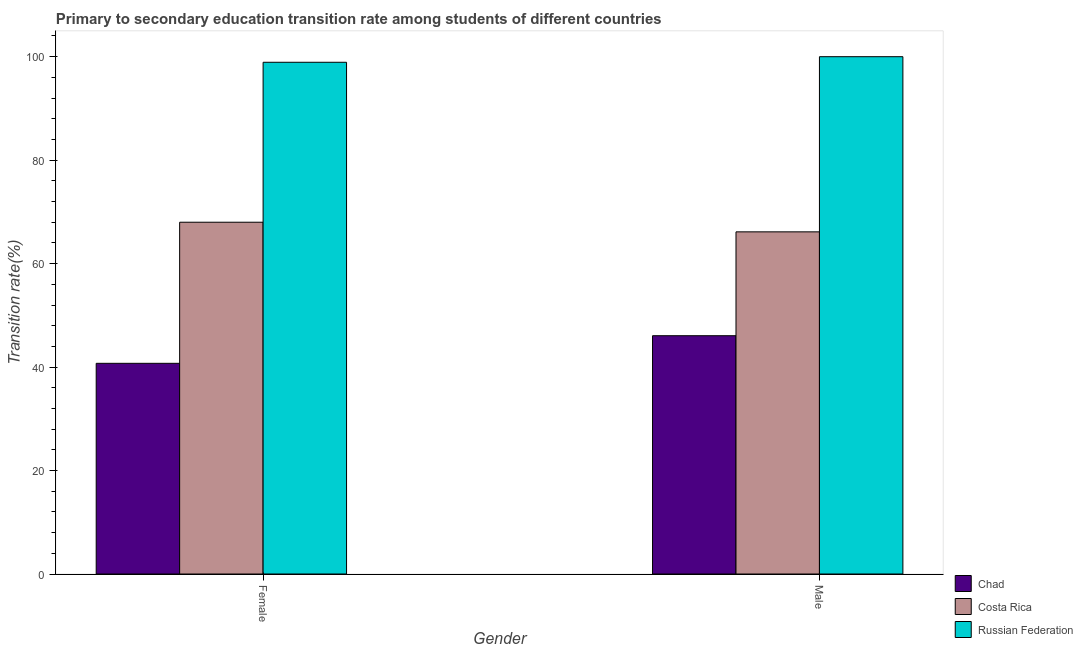How many different coloured bars are there?
Your answer should be very brief. 3. Are the number of bars per tick equal to the number of legend labels?
Offer a terse response. Yes. Are the number of bars on each tick of the X-axis equal?
Offer a very short reply. Yes. How many bars are there on the 1st tick from the left?
Keep it short and to the point. 3. How many bars are there on the 1st tick from the right?
Provide a succinct answer. 3. What is the label of the 2nd group of bars from the left?
Make the answer very short. Male. What is the transition rate among female students in Chad?
Provide a short and direct response. 40.73. Across all countries, what is the maximum transition rate among female students?
Your answer should be compact. 98.92. Across all countries, what is the minimum transition rate among female students?
Offer a terse response. 40.73. In which country was the transition rate among female students maximum?
Provide a short and direct response. Russian Federation. In which country was the transition rate among male students minimum?
Your answer should be very brief. Chad. What is the total transition rate among female students in the graph?
Provide a short and direct response. 207.65. What is the difference between the transition rate among male students in Russian Federation and that in Costa Rica?
Make the answer very short. 33.86. What is the difference between the transition rate among male students in Chad and the transition rate among female students in Russian Federation?
Make the answer very short. -52.86. What is the average transition rate among male students per country?
Give a very brief answer. 70.73. What is the difference between the transition rate among male students and transition rate among female students in Russian Federation?
Your response must be concise. 1.08. What is the ratio of the transition rate among female students in Costa Rica to that in Chad?
Offer a terse response. 1.67. Is the transition rate among male students in Russian Federation less than that in Chad?
Ensure brevity in your answer.  No. What does the 1st bar from the left in Male represents?
Your answer should be compact. Chad. What does the 2nd bar from the right in Male represents?
Give a very brief answer. Costa Rica. Are all the bars in the graph horizontal?
Your answer should be very brief. No. What is the difference between two consecutive major ticks on the Y-axis?
Your response must be concise. 20. Are the values on the major ticks of Y-axis written in scientific E-notation?
Keep it short and to the point. No. Does the graph contain grids?
Offer a very short reply. No. How are the legend labels stacked?
Keep it short and to the point. Vertical. What is the title of the graph?
Your answer should be compact. Primary to secondary education transition rate among students of different countries. Does "Nepal" appear as one of the legend labels in the graph?
Provide a succinct answer. No. What is the label or title of the Y-axis?
Offer a terse response. Transition rate(%). What is the Transition rate(%) of Chad in Female?
Ensure brevity in your answer.  40.73. What is the Transition rate(%) of Costa Rica in Female?
Offer a terse response. 68. What is the Transition rate(%) in Russian Federation in Female?
Give a very brief answer. 98.92. What is the Transition rate(%) of Chad in Male?
Provide a succinct answer. 46.06. What is the Transition rate(%) in Costa Rica in Male?
Your answer should be very brief. 66.14. Across all Gender, what is the maximum Transition rate(%) in Chad?
Provide a short and direct response. 46.06. Across all Gender, what is the maximum Transition rate(%) of Costa Rica?
Keep it short and to the point. 68. Across all Gender, what is the maximum Transition rate(%) in Russian Federation?
Offer a very short reply. 100. Across all Gender, what is the minimum Transition rate(%) of Chad?
Your answer should be very brief. 40.73. Across all Gender, what is the minimum Transition rate(%) of Costa Rica?
Give a very brief answer. 66.14. Across all Gender, what is the minimum Transition rate(%) in Russian Federation?
Make the answer very short. 98.92. What is the total Transition rate(%) of Chad in the graph?
Provide a succinct answer. 86.79. What is the total Transition rate(%) of Costa Rica in the graph?
Offer a very short reply. 134.14. What is the total Transition rate(%) of Russian Federation in the graph?
Keep it short and to the point. 198.92. What is the difference between the Transition rate(%) of Chad in Female and that in Male?
Keep it short and to the point. -5.34. What is the difference between the Transition rate(%) of Costa Rica in Female and that in Male?
Keep it short and to the point. 1.86. What is the difference between the Transition rate(%) in Russian Federation in Female and that in Male?
Offer a very short reply. -1.08. What is the difference between the Transition rate(%) of Chad in Female and the Transition rate(%) of Costa Rica in Male?
Keep it short and to the point. -25.42. What is the difference between the Transition rate(%) in Chad in Female and the Transition rate(%) in Russian Federation in Male?
Offer a terse response. -59.27. What is the difference between the Transition rate(%) of Costa Rica in Female and the Transition rate(%) of Russian Federation in Male?
Make the answer very short. -32. What is the average Transition rate(%) in Chad per Gender?
Your answer should be compact. 43.39. What is the average Transition rate(%) in Costa Rica per Gender?
Provide a succinct answer. 67.07. What is the average Transition rate(%) of Russian Federation per Gender?
Ensure brevity in your answer.  99.46. What is the difference between the Transition rate(%) of Chad and Transition rate(%) of Costa Rica in Female?
Your answer should be compact. -27.28. What is the difference between the Transition rate(%) in Chad and Transition rate(%) in Russian Federation in Female?
Your answer should be compact. -58.2. What is the difference between the Transition rate(%) in Costa Rica and Transition rate(%) in Russian Federation in Female?
Keep it short and to the point. -30.92. What is the difference between the Transition rate(%) of Chad and Transition rate(%) of Costa Rica in Male?
Make the answer very short. -20.08. What is the difference between the Transition rate(%) of Chad and Transition rate(%) of Russian Federation in Male?
Your response must be concise. -53.94. What is the difference between the Transition rate(%) of Costa Rica and Transition rate(%) of Russian Federation in Male?
Offer a very short reply. -33.86. What is the ratio of the Transition rate(%) in Chad in Female to that in Male?
Your response must be concise. 0.88. What is the ratio of the Transition rate(%) of Costa Rica in Female to that in Male?
Provide a succinct answer. 1.03. What is the difference between the highest and the second highest Transition rate(%) in Chad?
Provide a short and direct response. 5.34. What is the difference between the highest and the second highest Transition rate(%) of Costa Rica?
Make the answer very short. 1.86. What is the difference between the highest and the second highest Transition rate(%) in Russian Federation?
Keep it short and to the point. 1.08. What is the difference between the highest and the lowest Transition rate(%) of Chad?
Keep it short and to the point. 5.34. What is the difference between the highest and the lowest Transition rate(%) of Costa Rica?
Provide a short and direct response. 1.86. What is the difference between the highest and the lowest Transition rate(%) of Russian Federation?
Offer a terse response. 1.08. 